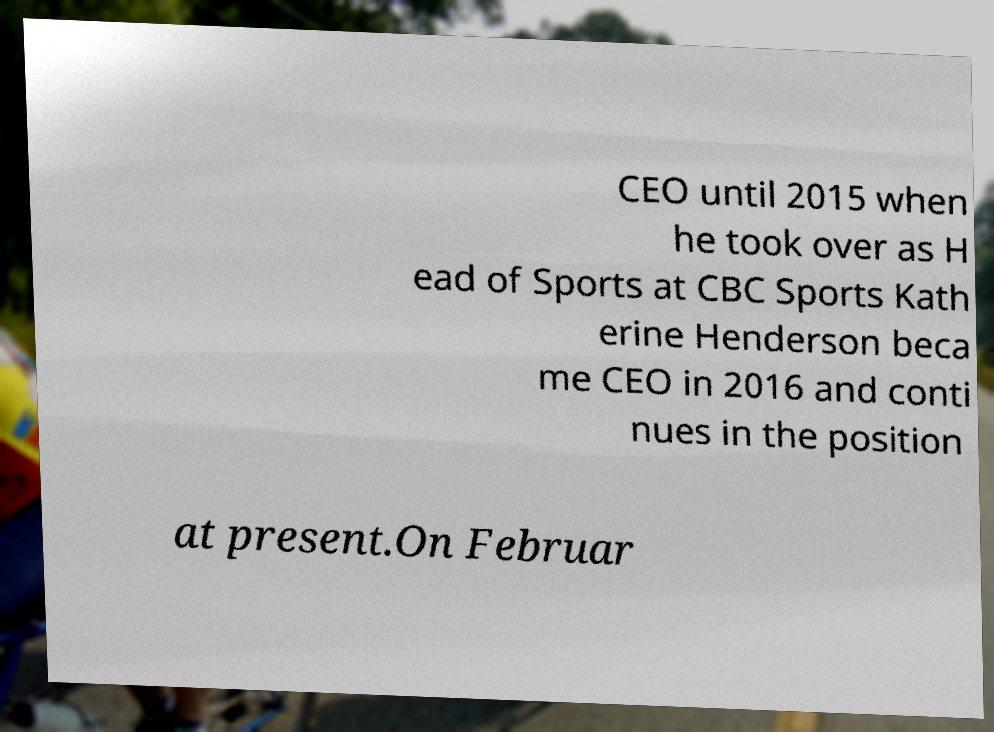Please identify and transcribe the text found in this image. CEO until 2015 when he took over as H ead of Sports at CBC Sports Kath erine Henderson beca me CEO in 2016 and conti nues in the position at present.On Februar 